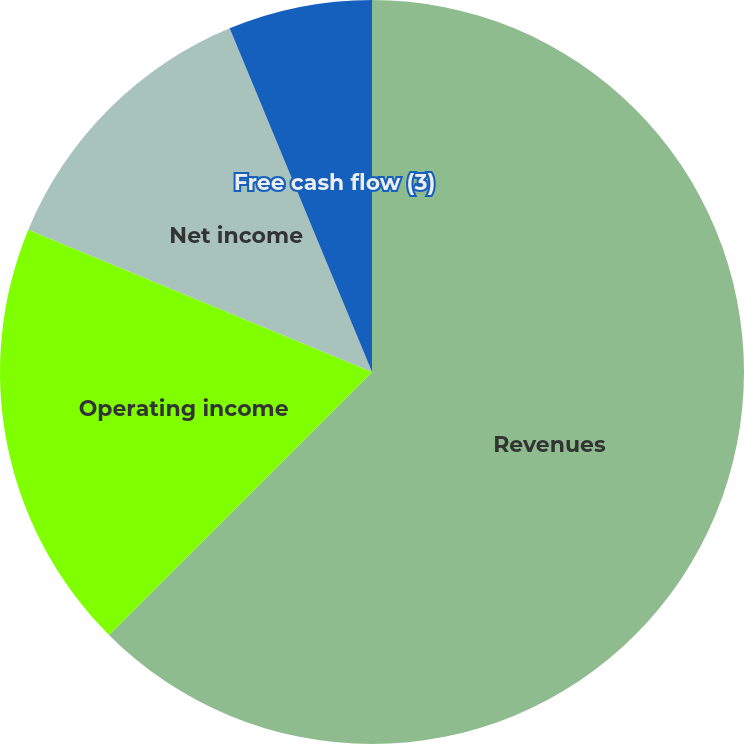Convert chart to OTSL. <chart><loc_0><loc_0><loc_500><loc_500><pie_chart><fcel>Revenues<fcel>Operating income<fcel>Net income<fcel>Net income per share-diluted<fcel>Free cash flow (3)<nl><fcel>62.5%<fcel>18.75%<fcel>12.5%<fcel>0.0%<fcel>6.25%<nl></chart> 